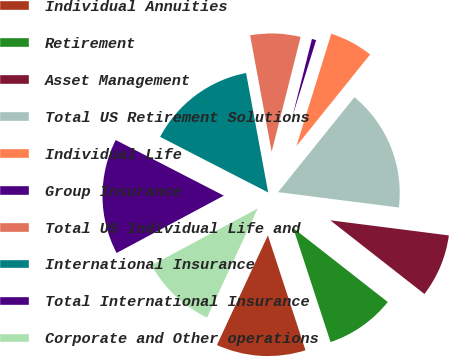<chart> <loc_0><loc_0><loc_500><loc_500><pie_chart><fcel>Individual Annuities<fcel>Retirement<fcel>Asset Management<fcel>Total US Retirement Solutions<fcel>Individual Life<fcel>Group Insurance<fcel>Total US Individual Life and<fcel>International Insurance<fcel>Total International Insurance<fcel>Corporate and Other operations<nl><fcel>11.96%<fcel>9.4%<fcel>8.55%<fcel>16.24%<fcel>5.99%<fcel>0.86%<fcel>6.84%<fcel>14.53%<fcel>15.38%<fcel>10.26%<nl></chart> 